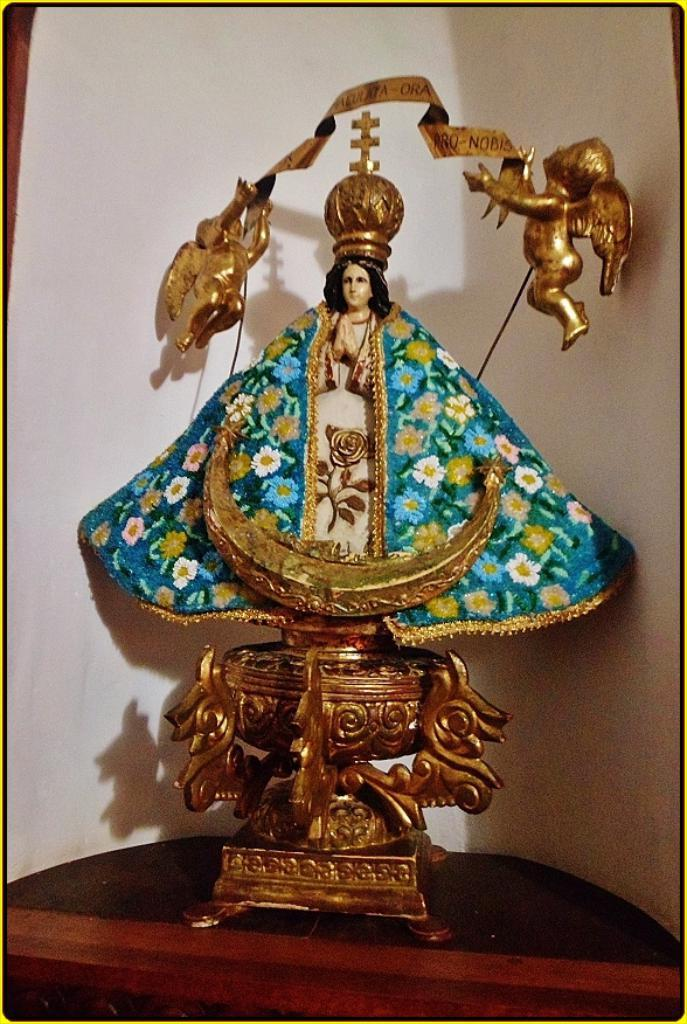What type of object can be seen in the image? There is a decorative object in the image. Where is the object placed? The object is kept on a shelf. What is the color of the decorative object? The object is gold in color. What can be seen behind the object? There is a wall behind the object. What type of twig can be seen growing out of the decorative object in the image? There is no twig present in the image; the decorative object is gold and kept on a shelf. 